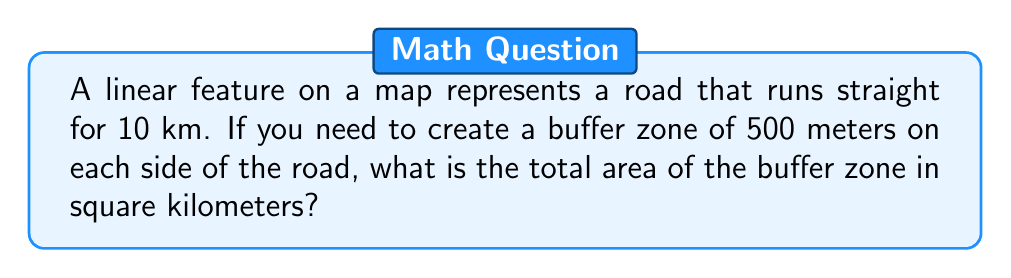Help me with this question. Let's approach this step-by-step:

1) The road is a straight line of length 10 km.

2) The buffer extends 500 m (0.5 km) on each side of the road.

3) This creates a rectangle with:
   - Length = road length = 10 km
   - Width = 2 * buffer distance = 2 * 0.5 km = 1 km

4) The shape of the buffer zone is a rectangle with two semicircles at the ends:

   [asy]
   import geometry;
   
   size(200);
   
   pair A = (0,0), B = (10,0);
   draw(A--B, blue);
   
   path p = box((0,-0.5),(10,0.5));
   filldraw(p, lightblue);
   
   filldraw(arc((0,0),0.5,90,270), lightblue);
   filldraw(arc((10,0),0.5,-90,90), lightblue);
   
   label("10 km", (5,0), S);
   label("0.5 km", (5,0.5), N);
   label("0.5 km", (5,-0.5), S);
   [/asy]

5) Area of the rectangle:
   $$A_r = 10 \text{ km} \times 1 \text{ km} = 10 \text{ km}^2$$

6) Area of each semicircle:
   $$A_s = \frac{1}{2} \pi r^2 = \frac{1}{2} \pi (0.5)^2 = \frac{1}{8} \pi \text{ km}^2$$

7) Total area:
   $$A_{\text{total}} = A_r + 2A_s = 10 + 2(\frac{1}{8} \pi) = 10 + \frac{1}{4} \pi \text{ km}^2$$

8) Calculating the final value:
   $$10 + \frac{1}{4} \pi \approx 10.7854 \text{ km}^2$$
Answer: $10 + \frac{1}{4} \pi \text{ km}^2$ (approximately 10.7854 km²) 